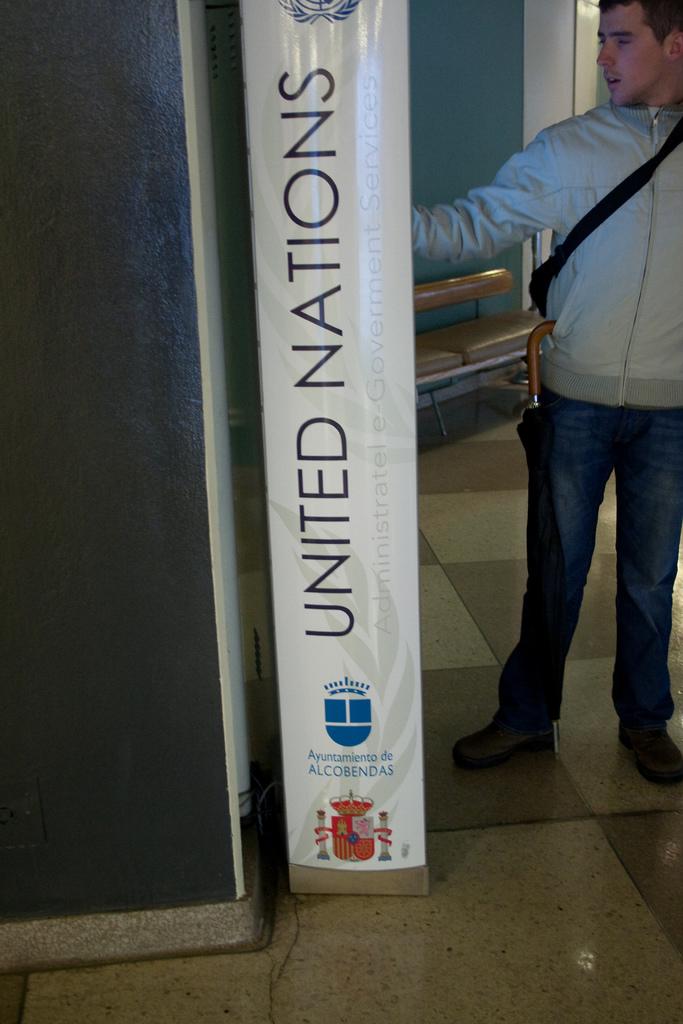What governmental entity is listed on the pillar?
Ensure brevity in your answer.  United nations. 